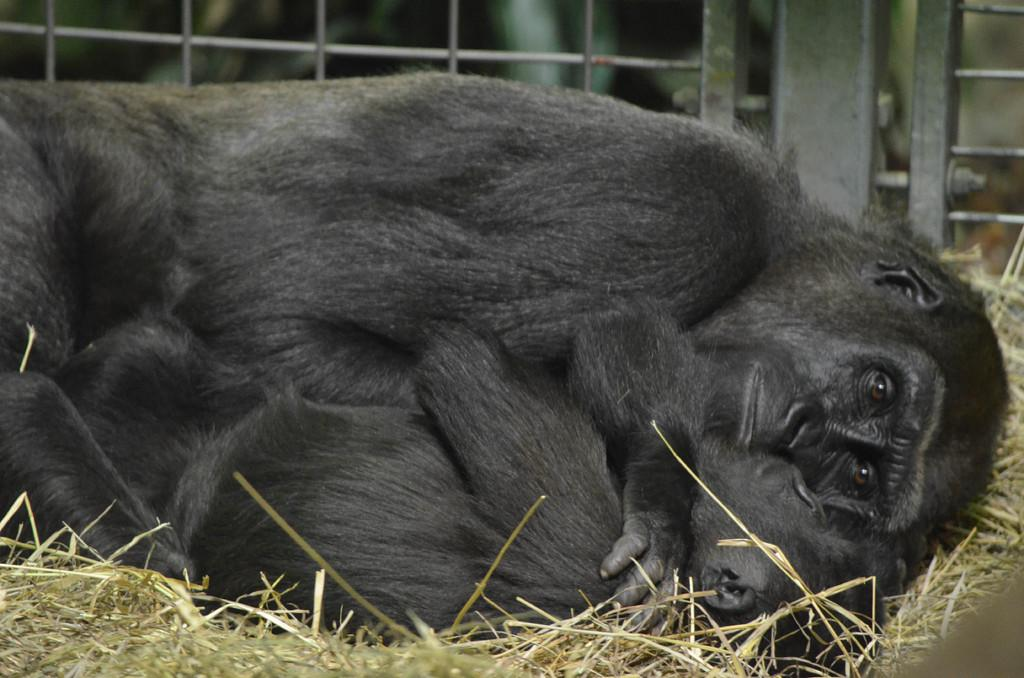How many chimpanzees are in the image? There are two chimpanzees in the image. Where are the chimpanzees located? The chimpanzees are on the grass. Is there any enclosure visible in the image? Yes, there is a cage in the image. What type of nail is the chimpanzee using to fix the truck in the image? There is no nail or truck present in the image; it features two chimpanzees on the grass and a cage. How does the chimpanzee's cough sound in the image? There is no mention of a cough in the image; it only shows two chimpanzees on the grass and a cage. 